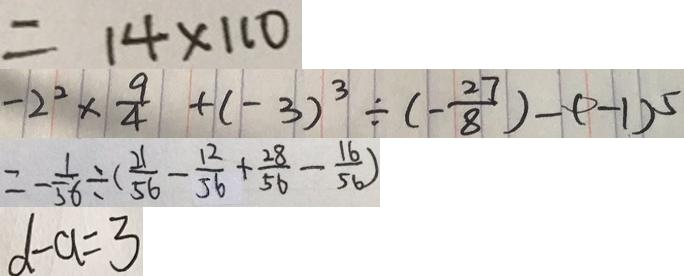Convert formula to latex. <formula><loc_0><loc_0><loc_500><loc_500>= 1 4 \times 1 1 0 
 - 2 ^ { 2 } \times \frac { 9 } { 4 } + ( - 3 ) ^ { 3 } \div ( - \frac { 2 7 } { 8 } ) - ( - 1 ) ^ { 5 } 
 = - \frac { 1 } { 5 6 } \div ( \frac { 2 1 } { 5 6 } - \frac { 1 2 } { 5 6 } + \frac { 2 8 } { 5 6 } - \frac { 1 6 } { 5 6 } ) 
 d - a = 3</formula> 